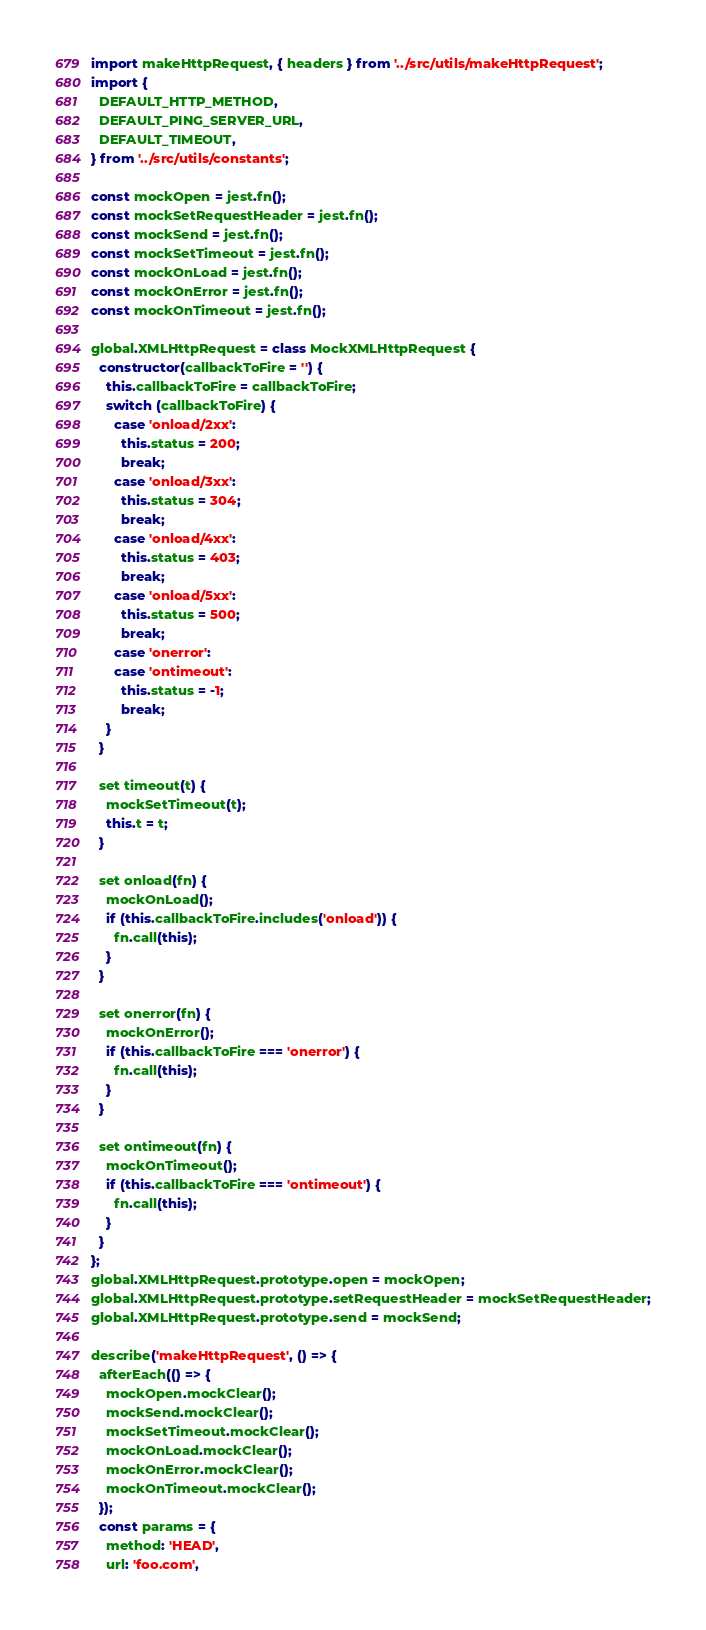Convert code to text. <code><loc_0><loc_0><loc_500><loc_500><_JavaScript_>import makeHttpRequest, { headers } from '../src/utils/makeHttpRequest';
import {
  DEFAULT_HTTP_METHOD,
  DEFAULT_PING_SERVER_URL,
  DEFAULT_TIMEOUT,
} from '../src/utils/constants';

const mockOpen = jest.fn();
const mockSetRequestHeader = jest.fn();
const mockSend = jest.fn();
const mockSetTimeout = jest.fn();
const mockOnLoad = jest.fn();
const mockOnError = jest.fn();
const mockOnTimeout = jest.fn();

global.XMLHttpRequest = class MockXMLHttpRequest {
  constructor(callbackToFire = '') {
    this.callbackToFire = callbackToFire;
    switch (callbackToFire) {
      case 'onload/2xx':
        this.status = 200;
        break;
      case 'onload/3xx':
        this.status = 304;
        break;
      case 'onload/4xx':
        this.status = 403;
        break;
      case 'onload/5xx':
        this.status = 500;
        break;
      case 'onerror':
      case 'ontimeout':
        this.status = -1;
        break;
    }
  }

  set timeout(t) {
    mockSetTimeout(t);
    this.t = t;
  }

  set onload(fn) {
    mockOnLoad();
    if (this.callbackToFire.includes('onload')) {
      fn.call(this);
    }
  }

  set onerror(fn) {
    mockOnError();
    if (this.callbackToFire === 'onerror') {
      fn.call(this);
    }
  }

  set ontimeout(fn) {
    mockOnTimeout();
    if (this.callbackToFire === 'ontimeout') {
      fn.call(this);
    }
  }
};
global.XMLHttpRequest.prototype.open = mockOpen;
global.XMLHttpRequest.prototype.setRequestHeader = mockSetRequestHeader;
global.XMLHttpRequest.prototype.send = mockSend;

describe('makeHttpRequest', () => {
  afterEach(() => {
    mockOpen.mockClear();
    mockSend.mockClear();
    mockSetTimeout.mockClear();
    mockOnLoad.mockClear();
    mockOnError.mockClear();
    mockOnTimeout.mockClear();
  });
  const params = {
    method: 'HEAD',
    url: 'foo.com',</code> 